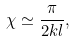<formula> <loc_0><loc_0><loc_500><loc_500>\chi \simeq \frac { \pi } { 2 k l } ,</formula> 